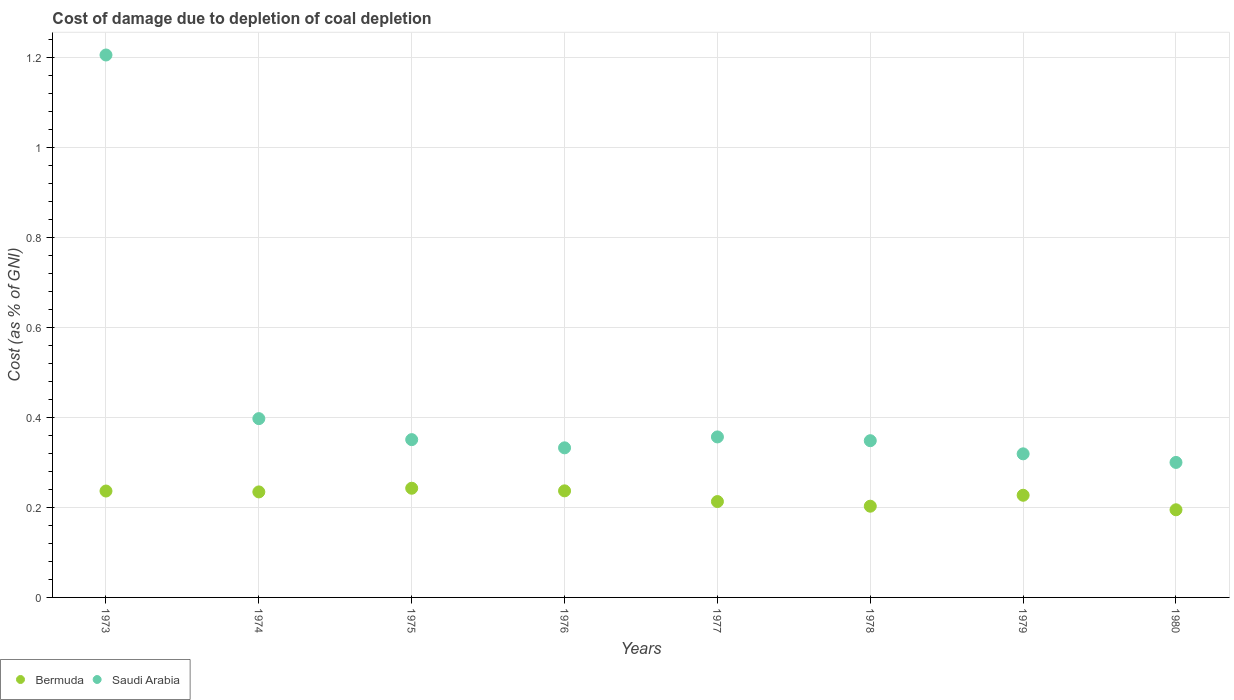Is the number of dotlines equal to the number of legend labels?
Your answer should be compact. Yes. What is the cost of damage caused due to coal depletion in Saudi Arabia in 1973?
Give a very brief answer. 1.21. Across all years, what is the maximum cost of damage caused due to coal depletion in Bermuda?
Offer a very short reply. 0.24. Across all years, what is the minimum cost of damage caused due to coal depletion in Bermuda?
Ensure brevity in your answer.  0.19. What is the total cost of damage caused due to coal depletion in Saudi Arabia in the graph?
Offer a very short reply. 3.61. What is the difference between the cost of damage caused due to coal depletion in Bermuda in 1977 and that in 1979?
Provide a succinct answer. -0.01. What is the difference between the cost of damage caused due to coal depletion in Bermuda in 1975 and the cost of damage caused due to coal depletion in Saudi Arabia in 1978?
Keep it short and to the point. -0.11. What is the average cost of damage caused due to coal depletion in Bermuda per year?
Offer a terse response. 0.22. In the year 1979, what is the difference between the cost of damage caused due to coal depletion in Bermuda and cost of damage caused due to coal depletion in Saudi Arabia?
Your answer should be very brief. -0.09. In how many years, is the cost of damage caused due to coal depletion in Bermuda greater than 0.28 %?
Offer a terse response. 0. What is the ratio of the cost of damage caused due to coal depletion in Saudi Arabia in 1976 to that in 1977?
Keep it short and to the point. 0.93. Is the difference between the cost of damage caused due to coal depletion in Bermuda in 1975 and 1977 greater than the difference between the cost of damage caused due to coal depletion in Saudi Arabia in 1975 and 1977?
Ensure brevity in your answer.  Yes. What is the difference between the highest and the second highest cost of damage caused due to coal depletion in Saudi Arabia?
Give a very brief answer. 0.81. What is the difference between the highest and the lowest cost of damage caused due to coal depletion in Bermuda?
Your response must be concise. 0.05. In how many years, is the cost of damage caused due to coal depletion in Bermuda greater than the average cost of damage caused due to coal depletion in Bermuda taken over all years?
Your response must be concise. 5. Is the sum of the cost of damage caused due to coal depletion in Bermuda in 1973 and 1976 greater than the maximum cost of damage caused due to coal depletion in Saudi Arabia across all years?
Make the answer very short. No. Does the cost of damage caused due to coal depletion in Bermuda monotonically increase over the years?
Your response must be concise. No. Is the cost of damage caused due to coal depletion in Bermuda strictly greater than the cost of damage caused due to coal depletion in Saudi Arabia over the years?
Make the answer very short. No. How many dotlines are there?
Offer a very short reply. 2. How many years are there in the graph?
Make the answer very short. 8. What is the difference between two consecutive major ticks on the Y-axis?
Offer a very short reply. 0.2. Are the values on the major ticks of Y-axis written in scientific E-notation?
Your response must be concise. No. Does the graph contain any zero values?
Provide a short and direct response. No. Does the graph contain grids?
Make the answer very short. Yes. Where does the legend appear in the graph?
Give a very brief answer. Bottom left. How many legend labels are there?
Provide a short and direct response. 2. What is the title of the graph?
Provide a short and direct response. Cost of damage due to depletion of coal depletion. What is the label or title of the X-axis?
Provide a succinct answer. Years. What is the label or title of the Y-axis?
Your response must be concise. Cost (as % of GNI). What is the Cost (as % of GNI) of Bermuda in 1973?
Give a very brief answer. 0.24. What is the Cost (as % of GNI) in Saudi Arabia in 1973?
Make the answer very short. 1.21. What is the Cost (as % of GNI) in Bermuda in 1974?
Offer a very short reply. 0.23. What is the Cost (as % of GNI) in Saudi Arabia in 1974?
Your response must be concise. 0.4. What is the Cost (as % of GNI) of Bermuda in 1975?
Provide a short and direct response. 0.24. What is the Cost (as % of GNI) in Saudi Arabia in 1975?
Keep it short and to the point. 0.35. What is the Cost (as % of GNI) of Bermuda in 1976?
Your response must be concise. 0.24. What is the Cost (as % of GNI) of Saudi Arabia in 1976?
Make the answer very short. 0.33. What is the Cost (as % of GNI) of Bermuda in 1977?
Keep it short and to the point. 0.21. What is the Cost (as % of GNI) in Saudi Arabia in 1977?
Offer a very short reply. 0.36. What is the Cost (as % of GNI) in Bermuda in 1978?
Provide a short and direct response. 0.2. What is the Cost (as % of GNI) of Saudi Arabia in 1978?
Give a very brief answer. 0.35. What is the Cost (as % of GNI) in Bermuda in 1979?
Ensure brevity in your answer.  0.23. What is the Cost (as % of GNI) in Saudi Arabia in 1979?
Your answer should be very brief. 0.32. What is the Cost (as % of GNI) of Bermuda in 1980?
Your answer should be compact. 0.19. What is the Cost (as % of GNI) of Saudi Arabia in 1980?
Ensure brevity in your answer.  0.3. Across all years, what is the maximum Cost (as % of GNI) in Bermuda?
Provide a short and direct response. 0.24. Across all years, what is the maximum Cost (as % of GNI) in Saudi Arabia?
Offer a very short reply. 1.21. Across all years, what is the minimum Cost (as % of GNI) in Bermuda?
Provide a short and direct response. 0.19. Across all years, what is the minimum Cost (as % of GNI) of Saudi Arabia?
Provide a short and direct response. 0.3. What is the total Cost (as % of GNI) of Bermuda in the graph?
Make the answer very short. 1.79. What is the total Cost (as % of GNI) in Saudi Arabia in the graph?
Make the answer very short. 3.61. What is the difference between the Cost (as % of GNI) of Bermuda in 1973 and that in 1974?
Provide a succinct answer. 0. What is the difference between the Cost (as % of GNI) in Saudi Arabia in 1973 and that in 1974?
Keep it short and to the point. 0.81. What is the difference between the Cost (as % of GNI) in Bermuda in 1973 and that in 1975?
Ensure brevity in your answer.  -0.01. What is the difference between the Cost (as % of GNI) in Saudi Arabia in 1973 and that in 1975?
Keep it short and to the point. 0.86. What is the difference between the Cost (as % of GNI) of Bermuda in 1973 and that in 1976?
Give a very brief answer. -0. What is the difference between the Cost (as % of GNI) of Saudi Arabia in 1973 and that in 1976?
Provide a short and direct response. 0.87. What is the difference between the Cost (as % of GNI) in Bermuda in 1973 and that in 1977?
Keep it short and to the point. 0.02. What is the difference between the Cost (as % of GNI) of Saudi Arabia in 1973 and that in 1977?
Your answer should be very brief. 0.85. What is the difference between the Cost (as % of GNI) in Bermuda in 1973 and that in 1978?
Make the answer very short. 0.03. What is the difference between the Cost (as % of GNI) of Saudi Arabia in 1973 and that in 1978?
Your answer should be compact. 0.86. What is the difference between the Cost (as % of GNI) of Bermuda in 1973 and that in 1979?
Offer a very short reply. 0.01. What is the difference between the Cost (as % of GNI) in Saudi Arabia in 1973 and that in 1979?
Offer a very short reply. 0.89. What is the difference between the Cost (as % of GNI) in Bermuda in 1973 and that in 1980?
Make the answer very short. 0.04. What is the difference between the Cost (as % of GNI) in Saudi Arabia in 1973 and that in 1980?
Make the answer very short. 0.91. What is the difference between the Cost (as % of GNI) in Bermuda in 1974 and that in 1975?
Keep it short and to the point. -0.01. What is the difference between the Cost (as % of GNI) of Saudi Arabia in 1974 and that in 1975?
Make the answer very short. 0.05. What is the difference between the Cost (as % of GNI) in Bermuda in 1974 and that in 1976?
Your answer should be compact. -0. What is the difference between the Cost (as % of GNI) in Saudi Arabia in 1974 and that in 1976?
Provide a succinct answer. 0.07. What is the difference between the Cost (as % of GNI) of Bermuda in 1974 and that in 1977?
Provide a succinct answer. 0.02. What is the difference between the Cost (as % of GNI) in Saudi Arabia in 1974 and that in 1977?
Keep it short and to the point. 0.04. What is the difference between the Cost (as % of GNI) in Bermuda in 1974 and that in 1978?
Provide a succinct answer. 0.03. What is the difference between the Cost (as % of GNI) of Saudi Arabia in 1974 and that in 1978?
Ensure brevity in your answer.  0.05. What is the difference between the Cost (as % of GNI) in Bermuda in 1974 and that in 1979?
Your answer should be compact. 0.01. What is the difference between the Cost (as % of GNI) in Saudi Arabia in 1974 and that in 1979?
Make the answer very short. 0.08. What is the difference between the Cost (as % of GNI) of Bermuda in 1974 and that in 1980?
Make the answer very short. 0.04. What is the difference between the Cost (as % of GNI) in Saudi Arabia in 1974 and that in 1980?
Give a very brief answer. 0.1. What is the difference between the Cost (as % of GNI) of Bermuda in 1975 and that in 1976?
Give a very brief answer. 0.01. What is the difference between the Cost (as % of GNI) of Saudi Arabia in 1975 and that in 1976?
Your answer should be very brief. 0.02. What is the difference between the Cost (as % of GNI) of Bermuda in 1975 and that in 1977?
Your response must be concise. 0.03. What is the difference between the Cost (as % of GNI) in Saudi Arabia in 1975 and that in 1977?
Provide a short and direct response. -0.01. What is the difference between the Cost (as % of GNI) of Saudi Arabia in 1975 and that in 1978?
Give a very brief answer. 0. What is the difference between the Cost (as % of GNI) of Bermuda in 1975 and that in 1979?
Offer a very short reply. 0.02. What is the difference between the Cost (as % of GNI) of Saudi Arabia in 1975 and that in 1979?
Keep it short and to the point. 0.03. What is the difference between the Cost (as % of GNI) of Bermuda in 1975 and that in 1980?
Offer a very short reply. 0.05. What is the difference between the Cost (as % of GNI) in Saudi Arabia in 1975 and that in 1980?
Your answer should be compact. 0.05. What is the difference between the Cost (as % of GNI) in Bermuda in 1976 and that in 1977?
Ensure brevity in your answer.  0.02. What is the difference between the Cost (as % of GNI) of Saudi Arabia in 1976 and that in 1977?
Offer a very short reply. -0.02. What is the difference between the Cost (as % of GNI) of Bermuda in 1976 and that in 1978?
Your answer should be very brief. 0.03. What is the difference between the Cost (as % of GNI) of Saudi Arabia in 1976 and that in 1978?
Provide a short and direct response. -0.02. What is the difference between the Cost (as % of GNI) of Bermuda in 1976 and that in 1979?
Ensure brevity in your answer.  0.01. What is the difference between the Cost (as % of GNI) in Saudi Arabia in 1976 and that in 1979?
Your answer should be very brief. 0.01. What is the difference between the Cost (as % of GNI) of Bermuda in 1976 and that in 1980?
Offer a very short reply. 0.04. What is the difference between the Cost (as % of GNI) of Saudi Arabia in 1976 and that in 1980?
Offer a very short reply. 0.03. What is the difference between the Cost (as % of GNI) of Bermuda in 1977 and that in 1978?
Make the answer very short. 0.01. What is the difference between the Cost (as % of GNI) in Saudi Arabia in 1977 and that in 1978?
Offer a terse response. 0.01. What is the difference between the Cost (as % of GNI) of Bermuda in 1977 and that in 1979?
Your answer should be compact. -0.01. What is the difference between the Cost (as % of GNI) of Saudi Arabia in 1977 and that in 1979?
Your response must be concise. 0.04. What is the difference between the Cost (as % of GNI) of Bermuda in 1977 and that in 1980?
Your answer should be compact. 0.02. What is the difference between the Cost (as % of GNI) in Saudi Arabia in 1977 and that in 1980?
Provide a short and direct response. 0.06. What is the difference between the Cost (as % of GNI) in Bermuda in 1978 and that in 1979?
Keep it short and to the point. -0.02. What is the difference between the Cost (as % of GNI) in Saudi Arabia in 1978 and that in 1979?
Offer a terse response. 0.03. What is the difference between the Cost (as % of GNI) in Bermuda in 1978 and that in 1980?
Provide a short and direct response. 0.01. What is the difference between the Cost (as % of GNI) of Saudi Arabia in 1978 and that in 1980?
Give a very brief answer. 0.05. What is the difference between the Cost (as % of GNI) in Bermuda in 1979 and that in 1980?
Your answer should be compact. 0.03. What is the difference between the Cost (as % of GNI) in Saudi Arabia in 1979 and that in 1980?
Provide a succinct answer. 0.02. What is the difference between the Cost (as % of GNI) of Bermuda in 1973 and the Cost (as % of GNI) of Saudi Arabia in 1974?
Your answer should be very brief. -0.16. What is the difference between the Cost (as % of GNI) in Bermuda in 1973 and the Cost (as % of GNI) in Saudi Arabia in 1975?
Ensure brevity in your answer.  -0.11. What is the difference between the Cost (as % of GNI) of Bermuda in 1973 and the Cost (as % of GNI) of Saudi Arabia in 1976?
Offer a very short reply. -0.1. What is the difference between the Cost (as % of GNI) in Bermuda in 1973 and the Cost (as % of GNI) in Saudi Arabia in 1977?
Your answer should be compact. -0.12. What is the difference between the Cost (as % of GNI) of Bermuda in 1973 and the Cost (as % of GNI) of Saudi Arabia in 1978?
Your answer should be compact. -0.11. What is the difference between the Cost (as % of GNI) in Bermuda in 1973 and the Cost (as % of GNI) in Saudi Arabia in 1979?
Your response must be concise. -0.08. What is the difference between the Cost (as % of GNI) in Bermuda in 1973 and the Cost (as % of GNI) in Saudi Arabia in 1980?
Your answer should be very brief. -0.06. What is the difference between the Cost (as % of GNI) in Bermuda in 1974 and the Cost (as % of GNI) in Saudi Arabia in 1975?
Make the answer very short. -0.12. What is the difference between the Cost (as % of GNI) of Bermuda in 1974 and the Cost (as % of GNI) of Saudi Arabia in 1976?
Offer a very short reply. -0.1. What is the difference between the Cost (as % of GNI) of Bermuda in 1974 and the Cost (as % of GNI) of Saudi Arabia in 1977?
Your response must be concise. -0.12. What is the difference between the Cost (as % of GNI) in Bermuda in 1974 and the Cost (as % of GNI) in Saudi Arabia in 1978?
Your answer should be very brief. -0.11. What is the difference between the Cost (as % of GNI) in Bermuda in 1974 and the Cost (as % of GNI) in Saudi Arabia in 1979?
Your answer should be compact. -0.08. What is the difference between the Cost (as % of GNI) in Bermuda in 1974 and the Cost (as % of GNI) in Saudi Arabia in 1980?
Provide a short and direct response. -0.07. What is the difference between the Cost (as % of GNI) of Bermuda in 1975 and the Cost (as % of GNI) of Saudi Arabia in 1976?
Ensure brevity in your answer.  -0.09. What is the difference between the Cost (as % of GNI) of Bermuda in 1975 and the Cost (as % of GNI) of Saudi Arabia in 1977?
Keep it short and to the point. -0.11. What is the difference between the Cost (as % of GNI) of Bermuda in 1975 and the Cost (as % of GNI) of Saudi Arabia in 1978?
Provide a short and direct response. -0.11. What is the difference between the Cost (as % of GNI) in Bermuda in 1975 and the Cost (as % of GNI) in Saudi Arabia in 1979?
Your answer should be compact. -0.08. What is the difference between the Cost (as % of GNI) in Bermuda in 1975 and the Cost (as % of GNI) in Saudi Arabia in 1980?
Provide a short and direct response. -0.06. What is the difference between the Cost (as % of GNI) in Bermuda in 1976 and the Cost (as % of GNI) in Saudi Arabia in 1977?
Your response must be concise. -0.12. What is the difference between the Cost (as % of GNI) in Bermuda in 1976 and the Cost (as % of GNI) in Saudi Arabia in 1978?
Provide a succinct answer. -0.11. What is the difference between the Cost (as % of GNI) of Bermuda in 1976 and the Cost (as % of GNI) of Saudi Arabia in 1979?
Provide a succinct answer. -0.08. What is the difference between the Cost (as % of GNI) in Bermuda in 1976 and the Cost (as % of GNI) in Saudi Arabia in 1980?
Give a very brief answer. -0.06. What is the difference between the Cost (as % of GNI) in Bermuda in 1977 and the Cost (as % of GNI) in Saudi Arabia in 1978?
Offer a terse response. -0.14. What is the difference between the Cost (as % of GNI) in Bermuda in 1977 and the Cost (as % of GNI) in Saudi Arabia in 1979?
Give a very brief answer. -0.11. What is the difference between the Cost (as % of GNI) of Bermuda in 1977 and the Cost (as % of GNI) of Saudi Arabia in 1980?
Provide a succinct answer. -0.09. What is the difference between the Cost (as % of GNI) in Bermuda in 1978 and the Cost (as % of GNI) in Saudi Arabia in 1979?
Your response must be concise. -0.12. What is the difference between the Cost (as % of GNI) of Bermuda in 1978 and the Cost (as % of GNI) of Saudi Arabia in 1980?
Provide a short and direct response. -0.1. What is the difference between the Cost (as % of GNI) in Bermuda in 1979 and the Cost (as % of GNI) in Saudi Arabia in 1980?
Provide a short and direct response. -0.07. What is the average Cost (as % of GNI) of Bermuda per year?
Your answer should be compact. 0.22. What is the average Cost (as % of GNI) of Saudi Arabia per year?
Your answer should be compact. 0.45. In the year 1973, what is the difference between the Cost (as % of GNI) in Bermuda and Cost (as % of GNI) in Saudi Arabia?
Your response must be concise. -0.97. In the year 1974, what is the difference between the Cost (as % of GNI) of Bermuda and Cost (as % of GNI) of Saudi Arabia?
Give a very brief answer. -0.16. In the year 1975, what is the difference between the Cost (as % of GNI) of Bermuda and Cost (as % of GNI) of Saudi Arabia?
Offer a terse response. -0.11. In the year 1976, what is the difference between the Cost (as % of GNI) of Bermuda and Cost (as % of GNI) of Saudi Arabia?
Offer a terse response. -0.1. In the year 1977, what is the difference between the Cost (as % of GNI) in Bermuda and Cost (as % of GNI) in Saudi Arabia?
Provide a short and direct response. -0.14. In the year 1978, what is the difference between the Cost (as % of GNI) of Bermuda and Cost (as % of GNI) of Saudi Arabia?
Ensure brevity in your answer.  -0.15. In the year 1979, what is the difference between the Cost (as % of GNI) in Bermuda and Cost (as % of GNI) in Saudi Arabia?
Make the answer very short. -0.09. In the year 1980, what is the difference between the Cost (as % of GNI) of Bermuda and Cost (as % of GNI) of Saudi Arabia?
Provide a short and direct response. -0.11. What is the ratio of the Cost (as % of GNI) of Bermuda in 1973 to that in 1974?
Ensure brevity in your answer.  1.01. What is the ratio of the Cost (as % of GNI) in Saudi Arabia in 1973 to that in 1974?
Offer a very short reply. 3.03. What is the ratio of the Cost (as % of GNI) of Bermuda in 1973 to that in 1975?
Make the answer very short. 0.97. What is the ratio of the Cost (as % of GNI) in Saudi Arabia in 1973 to that in 1975?
Make the answer very short. 3.44. What is the ratio of the Cost (as % of GNI) of Bermuda in 1973 to that in 1976?
Your answer should be very brief. 1. What is the ratio of the Cost (as % of GNI) in Saudi Arabia in 1973 to that in 1976?
Give a very brief answer. 3.63. What is the ratio of the Cost (as % of GNI) in Bermuda in 1973 to that in 1977?
Your response must be concise. 1.11. What is the ratio of the Cost (as % of GNI) in Saudi Arabia in 1973 to that in 1977?
Ensure brevity in your answer.  3.38. What is the ratio of the Cost (as % of GNI) of Bermuda in 1973 to that in 1978?
Your response must be concise. 1.17. What is the ratio of the Cost (as % of GNI) of Saudi Arabia in 1973 to that in 1978?
Keep it short and to the point. 3.46. What is the ratio of the Cost (as % of GNI) in Bermuda in 1973 to that in 1979?
Offer a very short reply. 1.04. What is the ratio of the Cost (as % of GNI) in Saudi Arabia in 1973 to that in 1979?
Provide a succinct answer. 3.78. What is the ratio of the Cost (as % of GNI) of Bermuda in 1973 to that in 1980?
Give a very brief answer. 1.21. What is the ratio of the Cost (as % of GNI) in Saudi Arabia in 1973 to that in 1980?
Offer a terse response. 4.02. What is the ratio of the Cost (as % of GNI) of Bermuda in 1974 to that in 1975?
Give a very brief answer. 0.97. What is the ratio of the Cost (as % of GNI) in Saudi Arabia in 1974 to that in 1975?
Give a very brief answer. 1.13. What is the ratio of the Cost (as % of GNI) of Bermuda in 1974 to that in 1976?
Give a very brief answer. 0.99. What is the ratio of the Cost (as % of GNI) of Saudi Arabia in 1974 to that in 1976?
Your answer should be very brief. 1.2. What is the ratio of the Cost (as % of GNI) in Bermuda in 1974 to that in 1977?
Your answer should be very brief. 1.1. What is the ratio of the Cost (as % of GNI) of Saudi Arabia in 1974 to that in 1977?
Provide a succinct answer. 1.11. What is the ratio of the Cost (as % of GNI) in Bermuda in 1974 to that in 1978?
Your answer should be compact. 1.16. What is the ratio of the Cost (as % of GNI) of Saudi Arabia in 1974 to that in 1978?
Keep it short and to the point. 1.14. What is the ratio of the Cost (as % of GNI) of Bermuda in 1974 to that in 1979?
Ensure brevity in your answer.  1.03. What is the ratio of the Cost (as % of GNI) in Saudi Arabia in 1974 to that in 1979?
Your answer should be very brief. 1.25. What is the ratio of the Cost (as % of GNI) of Bermuda in 1974 to that in 1980?
Your answer should be very brief. 1.2. What is the ratio of the Cost (as % of GNI) in Saudi Arabia in 1974 to that in 1980?
Provide a short and direct response. 1.32. What is the ratio of the Cost (as % of GNI) of Bermuda in 1975 to that in 1976?
Provide a succinct answer. 1.02. What is the ratio of the Cost (as % of GNI) of Saudi Arabia in 1975 to that in 1976?
Ensure brevity in your answer.  1.05. What is the ratio of the Cost (as % of GNI) of Bermuda in 1975 to that in 1977?
Offer a terse response. 1.14. What is the ratio of the Cost (as % of GNI) of Saudi Arabia in 1975 to that in 1977?
Keep it short and to the point. 0.98. What is the ratio of the Cost (as % of GNI) in Bermuda in 1975 to that in 1978?
Ensure brevity in your answer.  1.2. What is the ratio of the Cost (as % of GNI) in Saudi Arabia in 1975 to that in 1978?
Your response must be concise. 1.01. What is the ratio of the Cost (as % of GNI) in Bermuda in 1975 to that in 1979?
Ensure brevity in your answer.  1.07. What is the ratio of the Cost (as % of GNI) in Saudi Arabia in 1975 to that in 1979?
Your answer should be compact. 1.1. What is the ratio of the Cost (as % of GNI) of Bermuda in 1975 to that in 1980?
Offer a very short reply. 1.25. What is the ratio of the Cost (as % of GNI) of Saudi Arabia in 1975 to that in 1980?
Your answer should be very brief. 1.17. What is the ratio of the Cost (as % of GNI) of Bermuda in 1976 to that in 1977?
Make the answer very short. 1.11. What is the ratio of the Cost (as % of GNI) of Saudi Arabia in 1976 to that in 1977?
Your answer should be very brief. 0.93. What is the ratio of the Cost (as % of GNI) of Bermuda in 1976 to that in 1978?
Ensure brevity in your answer.  1.17. What is the ratio of the Cost (as % of GNI) in Saudi Arabia in 1976 to that in 1978?
Provide a short and direct response. 0.95. What is the ratio of the Cost (as % of GNI) in Bermuda in 1976 to that in 1979?
Provide a succinct answer. 1.04. What is the ratio of the Cost (as % of GNI) of Saudi Arabia in 1976 to that in 1979?
Your answer should be very brief. 1.04. What is the ratio of the Cost (as % of GNI) of Bermuda in 1976 to that in 1980?
Offer a very short reply. 1.22. What is the ratio of the Cost (as % of GNI) in Saudi Arabia in 1976 to that in 1980?
Provide a succinct answer. 1.11. What is the ratio of the Cost (as % of GNI) in Bermuda in 1977 to that in 1978?
Keep it short and to the point. 1.05. What is the ratio of the Cost (as % of GNI) in Saudi Arabia in 1977 to that in 1978?
Provide a succinct answer. 1.02. What is the ratio of the Cost (as % of GNI) of Bermuda in 1977 to that in 1979?
Provide a short and direct response. 0.94. What is the ratio of the Cost (as % of GNI) in Saudi Arabia in 1977 to that in 1979?
Offer a very short reply. 1.12. What is the ratio of the Cost (as % of GNI) of Bermuda in 1977 to that in 1980?
Keep it short and to the point. 1.09. What is the ratio of the Cost (as % of GNI) of Saudi Arabia in 1977 to that in 1980?
Your answer should be very brief. 1.19. What is the ratio of the Cost (as % of GNI) of Bermuda in 1978 to that in 1979?
Make the answer very short. 0.89. What is the ratio of the Cost (as % of GNI) in Saudi Arabia in 1978 to that in 1979?
Keep it short and to the point. 1.09. What is the ratio of the Cost (as % of GNI) in Bermuda in 1978 to that in 1980?
Give a very brief answer. 1.04. What is the ratio of the Cost (as % of GNI) in Saudi Arabia in 1978 to that in 1980?
Give a very brief answer. 1.16. What is the ratio of the Cost (as % of GNI) of Bermuda in 1979 to that in 1980?
Your answer should be very brief. 1.17. What is the ratio of the Cost (as % of GNI) in Saudi Arabia in 1979 to that in 1980?
Your answer should be compact. 1.06. What is the difference between the highest and the second highest Cost (as % of GNI) in Bermuda?
Give a very brief answer. 0.01. What is the difference between the highest and the second highest Cost (as % of GNI) of Saudi Arabia?
Your answer should be very brief. 0.81. What is the difference between the highest and the lowest Cost (as % of GNI) of Bermuda?
Make the answer very short. 0.05. What is the difference between the highest and the lowest Cost (as % of GNI) of Saudi Arabia?
Your response must be concise. 0.91. 